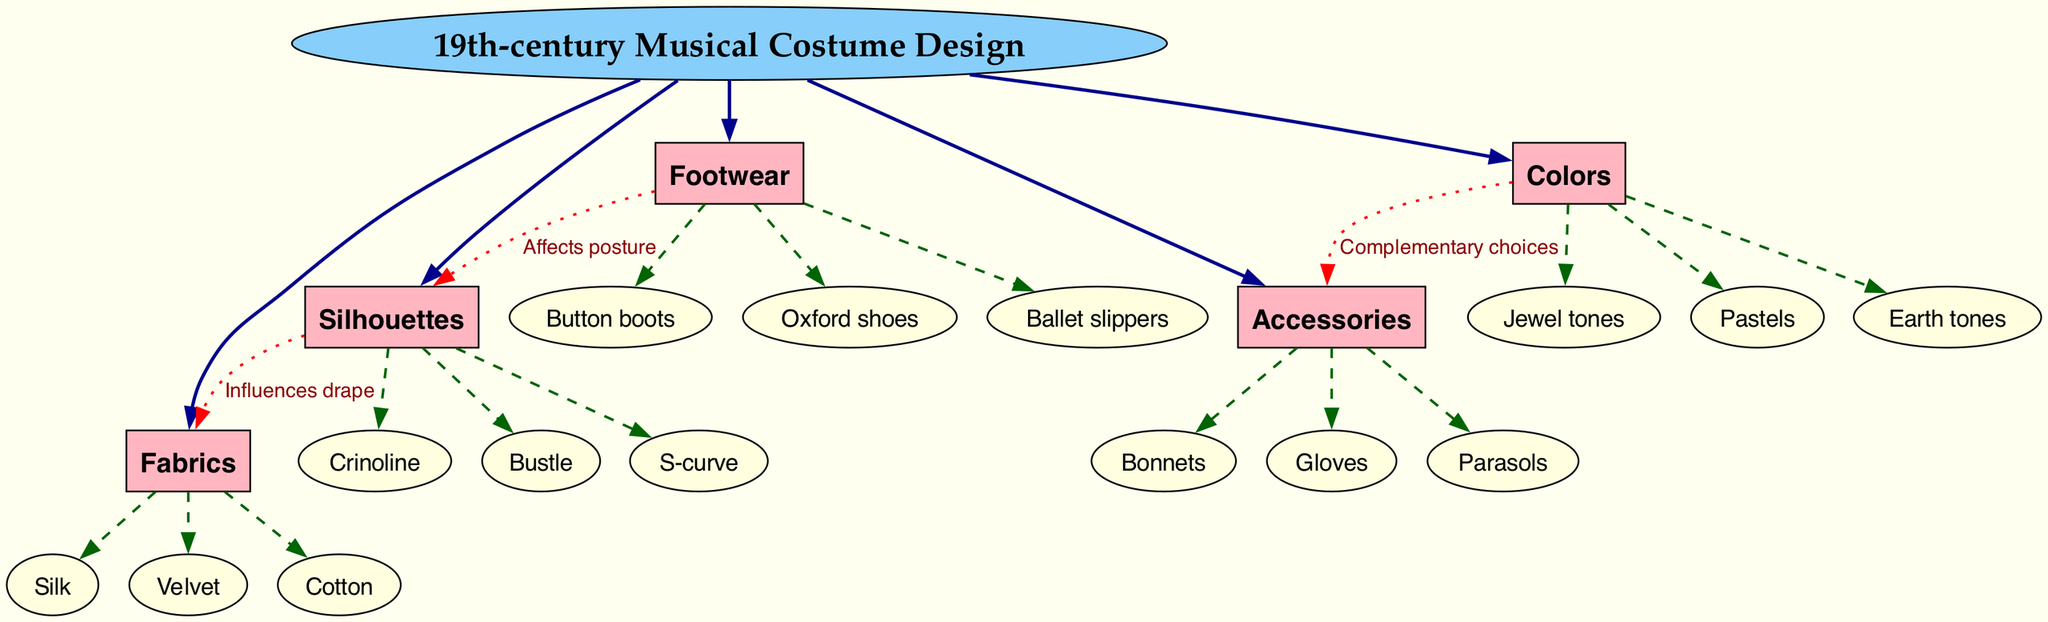What is the central topic of the diagram? The diagram highlights the central topic "19th-century Musical Costume Design," which is stated in the center of the diagram.
Answer: 19th-century Musical Costume Design How many main categories are present in the diagram? The diagram lists five main categories: Silhouettes, Fabrics, Accessories, Colors, and Footwear. Therefore, the total is five.
Answer: 5 What type of footwear is listed in the diagram? The subcategories under Footwear are Button boots, Oxford shoes, and Ballet slippers. These represent the options available under the Footwear category.
Answer: Button boots, Oxford shoes, Ballet slippers Which accessory is connected to the Colors category? The diagram indicates that Accessories are influenced by Colors, specifically through complementary choices. The Accessories listed include Bonnets, Gloves, and Parasols, but they all connect to the Colors category in the context of design.
Answer: Bonnets, Gloves, Parasols Which silhouette influences the drape of fabrics? The diagram shows a directional connection between Silhouettes and Fabrics, indicating that Silhouettes help to influence the drape of the Fabrics used in costume design.
Answer: Silhouettes What color category complements the Accessories? According to the diagram, the Colors category has a connection to Accessories through complementary choices, but it does not specify one exact color category for this; the subcategories listed are Jewel tones, Pastels, and Earth tones.
Answer: Jewel tones, Pastels, Earth tones How does footwear affect posture according to the diagram? The diagram indicates a relationship where Footwear affects Silhouettes, showing that the type of footwear chosen can influence the overall posture portrayed by the silhouettes in the costume designs.
Answer: Affects posture Explain the influence of Silhouettes on other elements in the diagram. Silhouettes have a direct connection to the Fabrics category, where they influence how the fabric drapes on the body. This means that the cut and style of the silhouette determine the flow and appearance of the fabric used. Furthermore, there is also an influence on Footwear, as the selection of footwear impacts the overall posture depicted by the silhouette.
Answer: Influences drape; Affects posture Which subcategory is related to the Bustle silhouette? The diagram does not specify an individual subcategory directly related to the Bustle silhouette, but it is included in the main category of Silhouettes which contains Crinoline, Bustle, and S-curve. This means it stands within the structure but does not connect directly to another item, so we refer to it as belonging to Silhouettes.
Answer: Bustle 